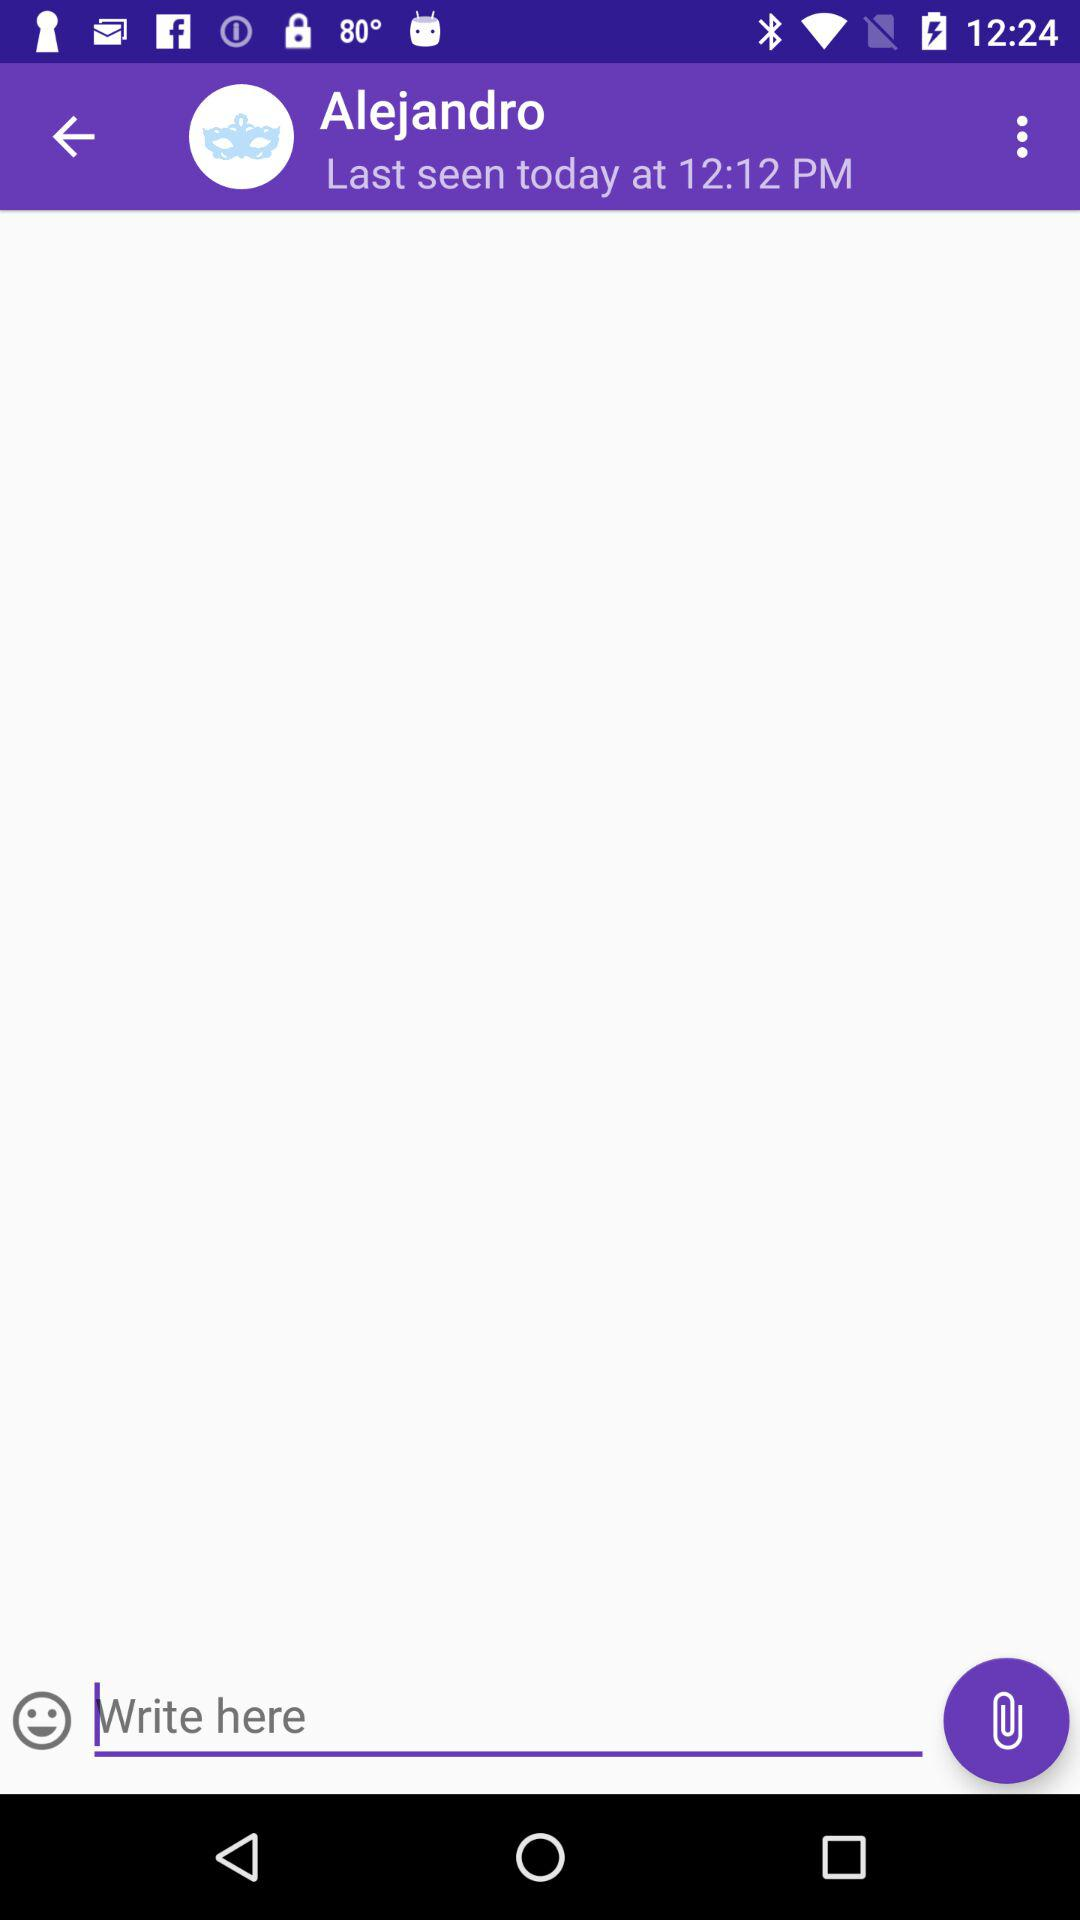What is the name? The name is Alejandro. 